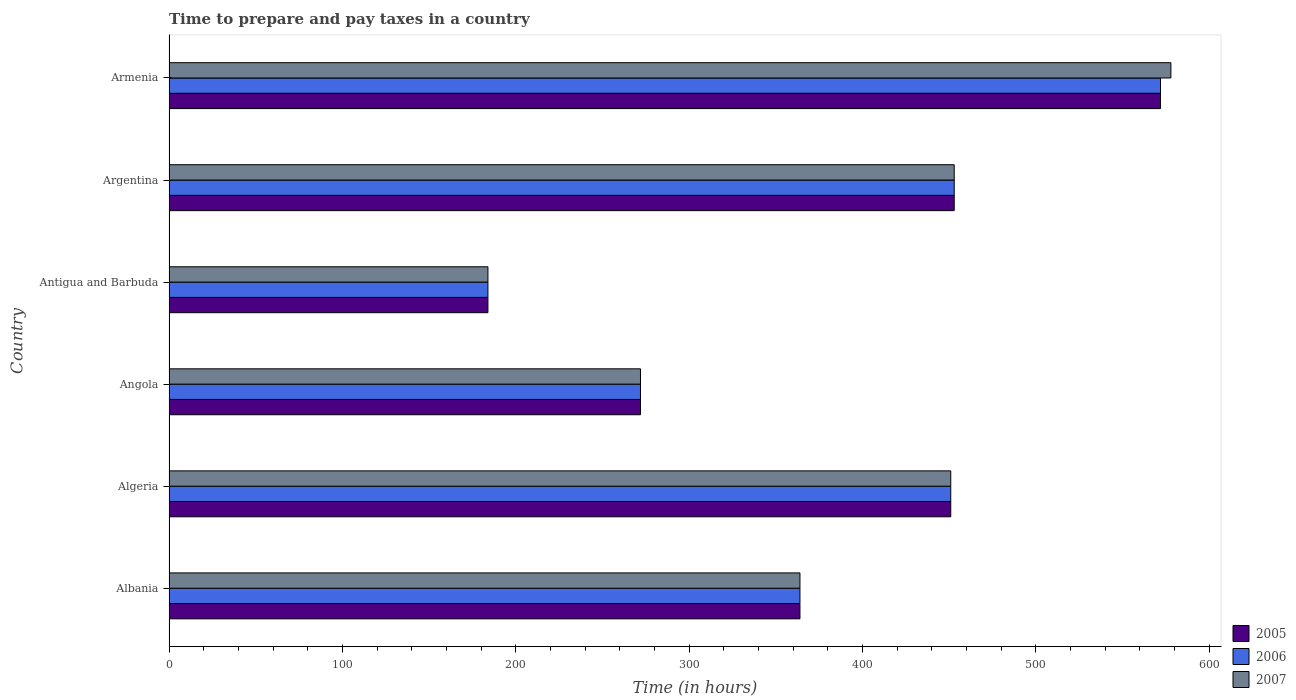How many different coloured bars are there?
Ensure brevity in your answer.  3. Are the number of bars per tick equal to the number of legend labels?
Make the answer very short. Yes. How many bars are there on the 2nd tick from the bottom?
Offer a terse response. 3. What is the label of the 6th group of bars from the top?
Provide a short and direct response. Albania. In how many cases, is the number of bars for a given country not equal to the number of legend labels?
Offer a terse response. 0. What is the number of hours required to prepare and pay taxes in 2005 in Argentina?
Your answer should be compact. 453. Across all countries, what is the maximum number of hours required to prepare and pay taxes in 2006?
Your answer should be very brief. 572. Across all countries, what is the minimum number of hours required to prepare and pay taxes in 2007?
Your response must be concise. 184. In which country was the number of hours required to prepare and pay taxes in 2007 maximum?
Offer a terse response. Armenia. In which country was the number of hours required to prepare and pay taxes in 2005 minimum?
Your answer should be compact. Antigua and Barbuda. What is the total number of hours required to prepare and pay taxes in 2006 in the graph?
Your response must be concise. 2296. What is the difference between the number of hours required to prepare and pay taxes in 2006 in Argentina and that in Armenia?
Your response must be concise. -119. What is the difference between the number of hours required to prepare and pay taxes in 2007 in Armenia and the number of hours required to prepare and pay taxes in 2006 in Angola?
Keep it short and to the point. 306. What is the average number of hours required to prepare and pay taxes in 2007 per country?
Give a very brief answer. 383.67. In how many countries, is the number of hours required to prepare and pay taxes in 2007 greater than 20 hours?
Your answer should be very brief. 6. What is the ratio of the number of hours required to prepare and pay taxes in 2006 in Angola to that in Armenia?
Your response must be concise. 0.48. Is the difference between the number of hours required to prepare and pay taxes in 2005 in Angola and Antigua and Barbuda greater than the difference between the number of hours required to prepare and pay taxes in 2007 in Angola and Antigua and Barbuda?
Make the answer very short. No. What is the difference between the highest and the second highest number of hours required to prepare and pay taxes in 2006?
Your response must be concise. 119. What is the difference between the highest and the lowest number of hours required to prepare and pay taxes in 2006?
Keep it short and to the point. 388. In how many countries, is the number of hours required to prepare and pay taxes in 2007 greater than the average number of hours required to prepare and pay taxes in 2007 taken over all countries?
Your answer should be very brief. 3. Is the sum of the number of hours required to prepare and pay taxes in 2007 in Albania and Argentina greater than the maximum number of hours required to prepare and pay taxes in 2006 across all countries?
Your answer should be compact. Yes. What does the 1st bar from the top in Albania represents?
Offer a terse response. 2007. How many bars are there?
Provide a succinct answer. 18. Are all the bars in the graph horizontal?
Offer a terse response. Yes. Does the graph contain any zero values?
Your response must be concise. No. Does the graph contain grids?
Ensure brevity in your answer.  No. How many legend labels are there?
Offer a very short reply. 3. How are the legend labels stacked?
Your response must be concise. Vertical. What is the title of the graph?
Ensure brevity in your answer.  Time to prepare and pay taxes in a country. Does "1991" appear as one of the legend labels in the graph?
Your answer should be very brief. No. What is the label or title of the X-axis?
Give a very brief answer. Time (in hours). What is the label or title of the Y-axis?
Provide a short and direct response. Country. What is the Time (in hours) in 2005 in Albania?
Ensure brevity in your answer.  364. What is the Time (in hours) of 2006 in Albania?
Give a very brief answer. 364. What is the Time (in hours) in 2007 in Albania?
Make the answer very short. 364. What is the Time (in hours) of 2005 in Algeria?
Ensure brevity in your answer.  451. What is the Time (in hours) in 2006 in Algeria?
Your answer should be compact. 451. What is the Time (in hours) in 2007 in Algeria?
Your response must be concise. 451. What is the Time (in hours) of 2005 in Angola?
Offer a very short reply. 272. What is the Time (in hours) of 2006 in Angola?
Offer a terse response. 272. What is the Time (in hours) in 2007 in Angola?
Give a very brief answer. 272. What is the Time (in hours) in 2005 in Antigua and Barbuda?
Keep it short and to the point. 184. What is the Time (in hours) in 2006 in Antigua and Barbuda?
Offer a terse response. 184. What is the Time (in hours) in 2007 in Antigua and Barbuda?
Make the answer very short. 184. What is the Time (in hours) in 2005 in Argentina?
Provide a short and direct response. 453. What is the Time (in hours) of 2006 in Argentina?
Keep it short and to the point. 453. What is the Time (in hours) of 2007 in Argentina?
Keep it short and to the point. 453. What is the Time (in hours) in 2005 in Armenia?
Offer a terse response. 572. What is the Time (in hours) of 2006 in Armenia?
Your answer should be very brief. 572. What is the Time (in hours) of 2007 in Armenia?
Provide a succinct answer. 578. Across all countries, what is the maximum Time (in hours) of 2005?
Make the answer very short. 572. Across all countries, what is the maximum Time (in hours) of 2006?
Offer a terse response. 572. Across all countries, what is the maximum Time (in hours) in 2007?
Provide a short and direct response. 578. Across all countries, what is the minimum Time (in hours) of 2005?
Offer a terse response. 184. Across all countries, what is the minimum Time (in hours) of 2006?
Your response must be concise. 184. Across all countries, what is the minimum Time (in hours) in 2007?
Your response must be concise. 184. What is the total Time (in hours) in 2005 in the graph?
Provide a succinct answer. 2296. What is the total Time (in hours) in 2006 in the graph?
Offer a terse response. 2296. What is the total Time (in hours) of 2007 in the graph?
Provide a short and direct response. 2302. What is the difference between the Time (in hours) of 2005 in Albania and that in Algeria?
Make the answer very short. -87. What is the difference between the Time (in hours) of 2006 in Albania and that in Algeria?
Your response must be concise. -87. What is the difference between the Time (in hours) of 2007 in Albania and that in Algeria?
Provide a short and direct response. -87. What is the difference between the Time (in hours) in 2005 in Albania and that in Angola?
Your response must be concise. 92. What is the difference between the Time (in hours) of 2006 in Albania and that in Angola?
Offer a very short reply. 92. What is the difference between the Time (in hours) in 2007 in Albania and that in Angola?
Provide a short and direct response. 92. What is the difference between the Time (in hours) in 2005 in Albania and that in Antigua and Barbuda?
Make the answer very short. 180. What is the difference between the Time (in hours) in 2006 in Albania and that in Antigua and Barbuda?
Give a very brief answer. 180. What is the difference between the Time (in hours) in 2007 in Albania and that in Antigua and Barbuda?
Give a very brief answer. 180. What is the difference between the Time (in hours) in 2005 in Albania and that in Argentina?
Provide a succinct answer. -89. What is the difference between the Time (in hours) in 2006 in Albania and that in Argentina?
Make the answer very short. -89. What is the difference between the Time (in hours) in 2007 in Albania and that in Argentina?
Your response must be concise. -89. What is the difference between the Time (in hours) in 2005 in Albania and that in Armenia?
Offer a very short reply. -208. What is the difference between the Time (in hours) in 2006 in Albania and that in Armenia?
Make the answer very short. -208. What is the difference between the Time (in hours) of 2007 in Albania and that in Armenia?
Provide a short and direct response. -214. What is the difference between the Time (in hours) of 2005 in Algeria and that in Angola?
Your answer should be compact. 179. What is the difference between the Time (in hours) of 2006 in Algeria and that in Angola?
Your response must be concise. 179. What is the difference between the Time (in hours) of 2007 in Algeria and that in Angola?
Ensure brevity in your answer.  179. What is the difference between the Time (in hours) in 2005 in Algeria and that in Antigua and Barbuda?
Make the answer very short. 267. What is the difference between the Time (in hours) in 2006 in Algeria and that in Antigua and Barbuda?
Your answer should be very brief. 267. What is the difference between the Time (in hours) in 2007 in Algeria and that in Antigua and Barbuda?
Keep it short and to the point. 267. What is the difference between the Time (in hours) of 2006 in Algeria and that in Argentina?
Offer a terse response. -2. What is the difference between the Time (in hours) in 2007 in Algeria and that in Argentina?
Give a very brief answer. -2. What is the difference between the Time (in hours) of 2005 in Algeria and that in Armenia?
Your response must be concise. -121. What is the difference between the Time (in hours) of 2006 in Algeria and that in Armenia?
Give a very brief answer. -121. What is the difference between the Time (in hours) in 2007 in Algeria and that in Armenia?
Provide a short and direct response. -127. What is the difference between the Time (in hours) of 2006 in Angola and that in Antigua and Barbuda?
Provide a succinct answer. 88. What is the difference between the Time (in hours) in 2007 in Angola and that in Antigua and Barbuda?
Your response must be concise. 88. What is the difference between the Time (in hours) of 2005 in Angola and that in Argentina?
Make the answer very short. -181. What is the difference between the Time (in hours) of 2006 in Angola and that in Argentina?
Make the answer very short. -181. What is the difference between the Time (in hours) in 2007 in Angola and that in Argentina?
Ensure brevity in your answer.  -181. What is the difference between the Time (in hours) in 2005 in Angola and that in Armenia?
Offer a terse response. -300. What is the difference between the Time (in hours) in 2006 in Angola and that in Armenia?
Keep it short and to the point. -300. What is the difference between the Time (in hours) of 2007 in Angola and that in Armenia?
Keep it short and to the point. -306. What is the difference between the Time (in hours) in 2005 in Antigua and Barbuda and that in Argentina?
Provide a short and direct response. -269. What is the difference between the Time (in hours) in 2006 in Antigua and Barbuda and that in Argentina?
Your answer should be very brief. -269. What is the difference between the Time (in hours) in 2007 in Antigua and Barbuda and that in Argentina?
Your answer should be very brief. -269. What is the difference between the Time (in hours) of 2005 in Antigua and Barbuda and that in Armenia?
Provide a succinct answer. -388. What is the difference between the Time (in hours) in 2006 in Antigua and Barbuda and that in Armenia?
Make the answer very short. -388. What is the difference between the Time (in hours) in 2007 in Antigua and Barbuda and that in Armenia?
Offer a very short reply. -394. What is the difference between the Time (in hours) of 2005 in Argentina and that in Armenia?
Ensure brevity in your answer.  -119. What is the difference between the Time (in hours) in 2006 in Argentina and that in Armenia?
Your response must be concise. -119. What is the difference between the Time (in hours) of 2007 in Argentina and that in Armenia?
Your response must be concise. -125. What is the difference between the Time (in hours) in 2005 in Albania and the Time (in hours) in 2006 in Algeria?
Make the answer very short. -87. What is the difference between the Time (in hours) in 2005 in Albania and the Time (in hours) in 2007 in Algeria?
Your response must be concise. -87. What is the difference between the Time (in hours) of 2006 in Albania and the Time (in hours) of 2007 in Algeria?
Ensure brevity in your answer.  -87. What is the difference between the Time (in hours) in 2005 in Albania and the Time (in hours) in 2006 in Angola?
Offer a very short reply. 92. What is the difference between the Time (in hours) of 2005 in Albania and the Time (in hours) of 2007 in Angola?
Give a very brief answer. 92. What is the difference between the Time (in hours) of 2006 in Albania and the Time (in hours) of 2007 in Angola?
Offer a very short reply. 92. What is the difference between the Time (in hours) of 2005 in Albania and the Time (in hours) of 2006 in Antigua and Barbuda?
Ensure brevity in your answer.  180. What is the difference between the Time (in hours) in 2005 in Albania and the Time (in hours) in 2007 in Antigua and Barbuda?
Make the answer very short. 180. What is the difference between the Time (in hours) in 2006 in Albania and the Time (in hours) in 2007 in Antigua and Barbuda?
Your answer should be compact. 180. What is the difference between the Time (in hours) of 2005 in Albania and the Time (in hours) of 2006 in Argentina?
Offer a very short reply. -89. What is the difference between the Time (in hours) in 2005 in Albania and the Time (in hours) in 2007 in Argentina?
Your answer should be very brief. -89. What is the difference between the Time (in hours) of 2006 in Albania and the Time (in hours) of 2007 in Argentina?
Your response must be concise. -89. What is the difference between the Time (in hours) of 2005 in Albania and the Time (in hours) of 2006 in Armenia?
Provide a succinct answer. -208. What is the difference between the Time (in hours) in 2005 in Albania and the Time (in hours) in 2007 in Armenia?
Provide a succinct answer. -214. What is the difference between the Time (in hours) in 2006 in Albania and the Time (in hours) in 2007 in Armenia?
Your response must be concise. -214. What is the difference between the Time (in hours) of 2005 in Algeria and the Time (in hours) of 2006 in Angola?
Offer a very short reply. 179. What is the difference between the Time (in hours) in 2005 in Algeria and the Time (in hours) in 2007 in Angola?
Keep it short and to the point. 179. What is the difference between the Time (in hours) of 2006 in Algeria and the Time (in hours) of 2007 in Angola?
Make the answer very short. 179. What is the difference between the Time (in hours) of 2005 in Algeria and the Time (in hours) of 2006 in Antigua and Barbuda?
Keep it short and to the point. 267. What is the difference between the Time (in hours) of 2005 in Algeria and the Time (in hours) of 2007 in Antigua and Barbuda?
Ensure brevity in your answer.  267. What is the difference between the Time (in hours) in 2006 in Algeria and the Time (in hours) in 2007 in Antigua and Barbuda?
Give a very brief answer. 267. What is the difference between the Time (in hours) of 2005 in Algeria and the Time (in hours) of 2006 in Argentina?
Offer a terse response. -2. What is the difference between the Time (in hours) of 2005 in Algeria and the Time (in hours) of 2007 in Argentina?
Offer a very short reply. -2. What is the difference between the Time (in hours) in 2005 in Algeria and the Time (in hours) in 2006 in Armenia?
Provide a succinct answer. -121. What is the difference between the Time (in hours) of 2005 in Algeria and the Time (in hours) of 2007 in Armenia?
Give a very brief answer. -127. What is the difference between the Time (in hours) in 2006 in Algeria and the Time (in hours) in 2007 in Armenia?
Offer a terse response. -127. What is the difference between the Time (in hours) of 2005 in Angola and the Time (in hours) of 2006 in Antigua and Barbuda?
Provide a succinct answer. 88. What is the difference between the Time (in hours) of 2005 in Angola and the Time (in hours) of 2007 in Antigua and Barbuda?
Offer a terse response. 88. What is the difference between the Time (in hours) in 2006 in Angola and the Time (in hours) in 2007 in Antigua and Barbuda?
Give a very brief answer. 88. What is the difference between the Time (in hours) of 2005 in Angola and the Time (in hours) of 2006 in Argentina?
Offer a very short reply. -181. What is the difference between the Time (in hours) of 2005 in Angola and the Time (in hours) of 2007 in Argentina?
Keep it short and to the point. -181. What is the difference between the Time (in hours) in 2006 in Angola and the Time (in hours) in 2007 in Argentina?
Offer a terse response. -181. What is the difference between the Time (in hours) in 2005 in Angola and the Time (in hours) in 2006 in Armenia?
Offer a terse response. -300. What is the difference between the Time (in hours) of 2005 in Angola and the Time (in hours) of 2007 in Armenia?
Your response must be concise. -306. What is the difference between the Time (in hours) in 2006 in Angola and the Time (in hours) in 2007 in Armenia?
Provide a short and direct response. -306. What is the difference between the Time (in hours) of 2005 in Antigua and Barbuda and the Time (in hours) of 2006 in Argentina?
Offer a terse response. -269. What is the difference between the Time (in hours) of 2005 in Antigua and Barbuda and the Time (in hours) of 2007 in Argentina?
Offer a very short reply. -269. What is the difference between the Time (in hours) in 2006 in Antigua and Barbuda and the Time (in hours) in 2007 in Argentina?
Give a very brief answer. -269. What is the difference between the Time (in hours) of 2005 in Antigua and Barbuda and the Time (in hours) of 2006 in Armenia?
Ensure brevity in your answer.  -388. What is the difference between the Time (in hours) in 2005 in Antigua and Barbuda and the Time (in hours) in 2007 in Armenia?
Ensure brevity in your answer.  -394. What is the difference between the Time (in hours) in 2006 in Antigua and Barbuda and the Time (in hours) in 2007 in Armenia?
Your response must be concise. -394. What is the difference between the Time (in hours) of 2005 in Argentina and the Time (in hours) of 2006 in Armenia?
Your answer should be very brief. -119. What is the difference between the Time (in hours) of 2005 in Argentina and the Time (in hours) of 2007 in Armenia?
Your answer should be compact. -125. What is the difference between the Time (in hours) in 2006 in Argentina and the Time (in hours) in 2007 in Armenia?
Your answer should be very brief. -125. What is the average Time (in hours) in 2005 per country?
Offer a very short reply. 382.67. What is the average Time (in hours) in 2006 per country?
Offer a terse response. 382.67. What is the average Time (in hours) in 2007 per country?
Give a very brief answer. 383.67. What is the difference between the Time (in hours) of 2006 and Time (in hours) of 2007 in Albania?
Ensure brevity in your answer.  0. What is the difference between the Time (in hours) of 2005 and Time (in hours) of 2006 in Algeria?
Give a very brief answer. 0. What is the difference between the Time (in hours) in 2005 and Time (in hours) in 2007 in Algeria?
Your answer should be very brief. 0. What is the difference between the Time (in hours) of 2005 and Time (in hours) of 2006 in Angola?
Your answer should be compact. 0. What is the difference between the Time (in hours) in 2005 and Time (in hours) in 2007 in Angola?
Your answer should be very brief. 0. What is the difference between the Time (in hours) of 2005 and Time (in hours) of 2007 in Antigua and Barbuda?
Keep it short and to the point. 0. What is the difference between the Time (in hours) in 2005 and Time (in hours) in 2006 in Argentina?
Your answer should be very brief. 0. What is the difference between the Time (in hours) in 2005 and Time (in hours) in 2007 in Argentina?
Offer a very short reply. 0. What is the difference between the Time (in hours) in 2005 and Time (in hours) in 2006 in Armenia?
Make the answer very short. 0. What is the ratio of the Time (in hours) of 2005 in Albania to that in Algeria?
Make the answer very short. 0.81. What is the ratio of the Time (in hours) in 2006 in Albania to that in Algeria?
Offer a terse response. 0.81. What is the ratio of the Time (in hours) of 2007 in Albania to that in Algeria?
Offer a terse response. 0.81. What is the ratio of the Time (in hours) in 2005 in Albania to that in Angola?
Your answer should be compact. 1.34. What is the ratio of the Time (in hours) in 2006 in Albania to that in Angola?
Your answer should be compact. 1.34. What is the ratio of the Time (in hours) in 2007 in Albania to that in Angola?
Your response must be concise. 1.34. What is the ratio of the Time (in hours) in 2005 in Albania to that in Antigua and Barbuda?
Keep it short and to the point. 1.98. What is the ratio of the Time (in hours) of 2006 in Albania to that in Antigua and Barbuda?
Give a very brief answer. 1.98. What is the ratio of the Time (in hours) of 2007 in Albania to that in Antigua and Barbuda?
Ensure brevity in your answer.  1.98. What is the ratio of the Time (in hours) of 2005 in Albania to that in Argentina?
Provide a short and direct response. 0.8. What is the ratio of the Time (in hours) in 2006 in Albania to that in Argentina?
Your answer should be compact. 0.8. What is the ratio of the Time (in hours) of 2007 in Albania to that in Argentina?
Provide a succinct answer. 0.8. What is the ratio of the Time (in hours) in 2005 in Albania to that in Armenia?
Give a very brief answer. 0.64. What is the ratio of the Time (in hours) of 2006 in Albania to that in Armenia?
Provide a succinct answer. 0.64. What is the ratio of the Time (in hours) in 2007 in Albania to that in Armenia?
Provide a short and direct response. 0.63. What is the ratio of the Time (in hours) of 2005 in Algeria to that in Angola?
Provide a succinct answer. 1.66. What is the ratio of the Time (in hours) of 2006 in Algeria to that in Angola?
Provide a short and direct response. 1.66. What is the ratio of the Time (in hours) in 2007 in Algeria to that in Angola?
Your response must be concise. 1.66. What is the ratio of the Time (in hours) in 2005 in Algeria to that in Antigua and Barbuda?
Make the answer very short. 2.45. What is the ratio of the Time (in hours) of 2006 in Algeria to that in Antigua and Barbuda?
Ensure brevity in your answer.  2.45. What is the ratio of the Time (in hours) of 2007 in Algeria to that in Antigua and Barbuda?
Provide a succinct answer. 2.45. What is the ratio of the Time (in hours) of 2006 in Algeria to that in Argentina?
Keep it short and to the point. 1. What is the ratio of the Time (in hours) in 2005 in Algeria to that in Armenia?
Provide a short and direct response. 0.79. What is the ratio of the Time (in hours) of 2006 in Algeria to that in Armenia?
Provide a short and direct response. 0.79. What is the ratio of the Time (in hours) of 2007 in Algeria to that in Armenia?
Provide a short and direct response. 0.78. What is the ratio of the Time (in hours) of 2005 in Angola to that in Antigua and Barbuda?
Offer a very short reply. 1.48. What is the ratio of the Time (in hours) of 2006 in Angola to that in Antigua and Barbuda?
Your answer should be compact. 1.48. What is the ratio of the Time (in hours) in 2007 in Angola to that in Antigua and Barbuda?
Your response must be concise. 1.48. What is the ratio of the Time (in hours) in 2005 in Angola to that in Argentina?
Your response must be concise. 0.6. What is the ratio of the Time (in hours) of 2006 in Angola to that in Argentina?
Provide a short and direct response. 0.6. What is the ratio of the Time (in hours) of 2007 in Angola to that in Argentina?
Give a very brief answer. 0.6. What is the ratio of the Time (in hours) of 2005 in Angola to that in Armenia?
Offer a very short reply. 0.48. What is the ratio of the Time (in hours) in 2006 in Angola to that in Armenia?
Offer a very short reply. 0.48. What is the ratio of the Time (in hours) of 2007 in Angola to that in Armenia?
Make the answer very short. 0.47. What is the ratio of the Time (in hours) of 2005 in Antigua and Barbuda to that in Argentina?
Your answer should be very brief. 0.41. What is the ratio of the Time (in hours) of 2006 in Antigua and Barbuda to that in Argentina?
Offer a terse response. 0.41. What is the ratio of the Time (in hours) of 2007 in Antigua and Barbuda to that in Argentina?
Make the answer very short. 0.41. What is the ratio of the Time (in hours) in 2005 in Antigua and Barbuda to that in Armenia?
Keep it short and to the point. 0.32. What is the ratio of the Time (in hours) of 2006 in Antigua and Barbuda to that in Armenia?
Provide a succinct answer. 0.32. What is the ratio of the Time (in hours) of 2007 in Antigua and Barbuda to that in Armenia?
Provide a succinct answer. 0.32. What is the ratio of the Time (in hours) in 2005 in Argentina to that in Armenia?
Make the answer very short. 0.79. What is the ratio of the Time (in hours) of 2006 in Argentina to that in Armenia?
Keep it short and to the point. 0.79. What is the ratio of the Time (in hours) in 2007 in Argentina to that in Armenia?
Your response must be concise. 0.78. What is the difference between the highest and the second highest Time (in hours) in 2005?
Your answer should be compact. 119. What is the difference between the highest and the second highest Time (in hours) in 2006?
Offer a very short reply. 119. What is the difference between the highest and the second highest Time (in hours) in 2007?
Offer a very short reply. 125. What is the difference between the highest and the lowest Time (in hours) in 2005?
Your answer should be very brief. 388. What is the difference between the highest and the lowest Time (in hours) of 2006?
Give a very brief answer. 388. What is the difference between the highest and the lowest Time (in hours) in 2007?
Your response must be concise. 394. 